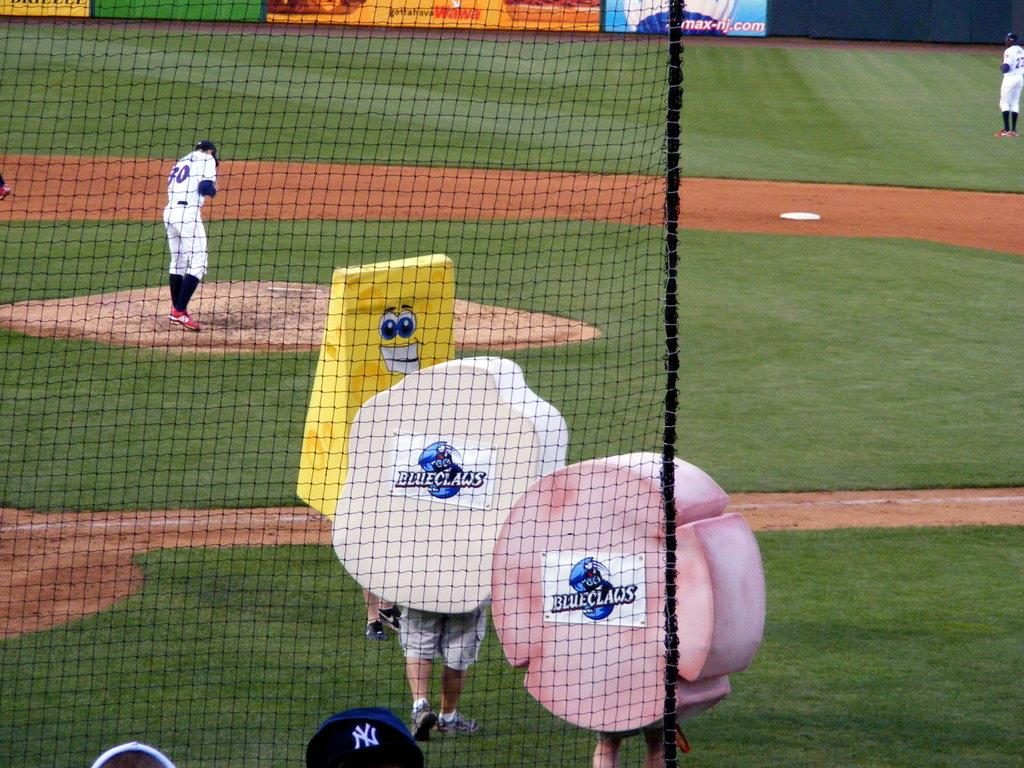<image>
Offer a succinct explanation of the picture presented. Three odd looking mascots with a blueclaws logo leave a baseball field as the players prepare to play. 